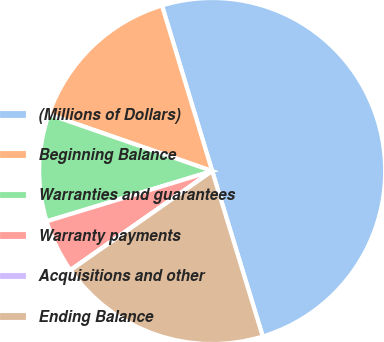Convert chart. <chart><loc_0><loc_0><loc_500><loc_500><pie_chart><fcel>(Millions of Dollars)<fcel>Beginning Balance<fcel>Warranties and guarantees<fcel>Warranty payments<fcel>Acquisitions and other<fcel>Ending Balance<nl><fcel>49.97%<fcel>15.0%<fcel>10.01%<fcel>5.01%<fcel>0.02%<fcel>20.0%<nl></chart> 